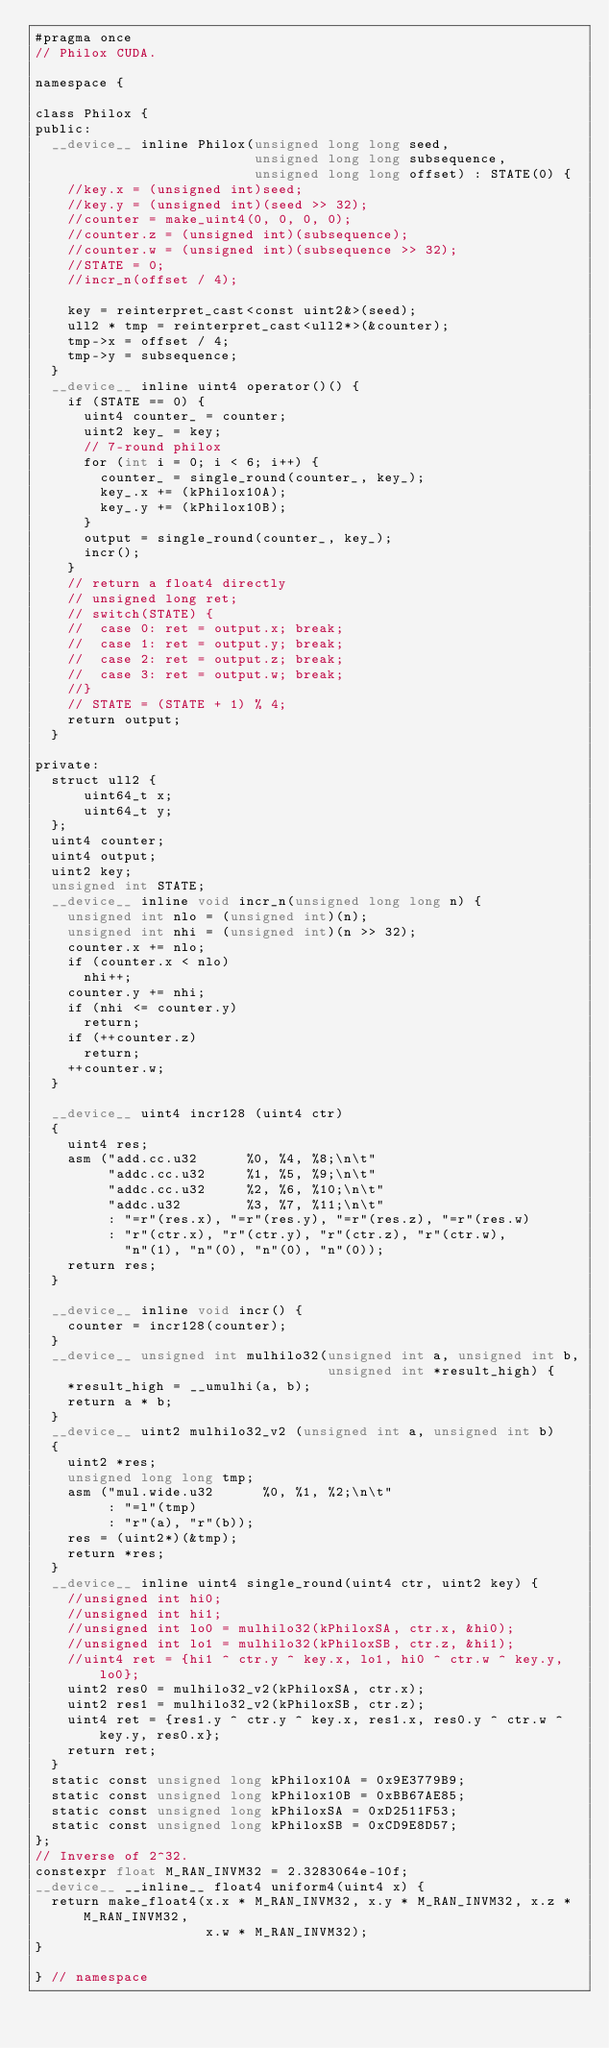<code> <loc_0><loc_0><loc_500><loc_500><_Cuda_>#pragma once
// Philox CUDA.

namespace {

class Philox {
public:
  __device__ inline Philox(unsigned long long seed,
                           unsigned long long subsequence,
                           unsigned long long offset) : STATE(0) {
    //key.x = (unsigned int)seed;
    //key.y = (unsigned int)(seed >> 32);
    //counter = make_uint4(0, 0, 0, 0);
    //counter.z = (unsigned int)(subsequence);
    //counter.w = (unsigned int)(subsequence >> 32);
    //STATE = 0;
    //incr_n(offset / 4);

    key = reinterpret_cast<const uint2&>(seed);
    ull2 * tmp = reinterpret_cast<ull2*>(&counter);
    tmp->x = offset / 4;
    tmp->y = subsequence;
  }
  __device__ inline uint4 operator()() {
    if (STATE == 0) {
      uint4 counter_ = counter;
      uint2 key_ = key;
      // 7-round philox
      for (int i = 0; i < 6; i++) {
        counter_ = single_round(counter_, key_);
        key_.x += (kPhilox10A);
        key_.y += (kPhilox10B);
      }
      output = single_round(counter_, key_);
      incr();
    }
    // return a float4 directly
    // unsigned long ret;
    // switch(STATE) {
    //  case 0: ret = output.x; break;
    //  case 1: ret = output.y; break;
    //  case 2: ret = output.z; break;
    //  case 3: ret = output.w; break;
    //}
    // STATE = (STATE + 1) % 4;
    return output;
  }

private:
  struct ull2 {
      uint64_t x;
      uint64_t y;
  };
  uint4 counter;
  uint4 output;
  uint2 key;
  unsigned int STATE;
  __device__ inline void incr_n(unsigned long long n) {
    unsigned int nlo = (unsigned int)(n);
    unsigned int nhi = (unsigned int)(n >> 32);
    counter.x += nlo;
    if (counter.x < nlo)
      nhi++;
    counter.y += nhi;
    if (nhi <= counter.y)
      return;
    if (++counter.z)
      return;
    ++counter.w;
  }

  __device__ uint4 incr128 (uint4 ctr)
  {
    uint4 res;
    asm ("add.cc.u32      %0, %4, %8;\n\t"
         "addc.cc.u32     %1, %5, %9;\n\t"
         "addc.cc.u32     %2, %6, %10;\n\t"
         "addc.u32        %3, %7, %11;\n\t"
         : "=r"(res.x), "=r"(res.y), "=r"(res.z), "=r"(res.w)
         : "r"(ctr.x), "r"(ctr.y), "r"(ctr.z), "r"(ctr.w),
           "n"(1), "n"(0), "n"(0), "n"(0));
    return res;
  }

  __device__ inline void incr() {
    counter = incr128(counter);
  }
  __device__ unsigned int mulhilo32(unsigned int a, unsigned int b,
                                    unsigned int *result_high) {
    *result_high = __umulhi(a, b);
    return a * b;
  }
  __device__ uint2 mulhilo32_v2 (unsigned int a, unsigned int b)
  {
    uint2 *res;
    unsigned long long tmp;
    asm ("mul.wide.u32      %0, %1, %2;\n\t"
         : "=l"(tmp)
         : "r"(a), "r"(b));
    res = (uint2*)(&tmp);
    return *res;
  }
  __device__ inline uint4 single_round(uint4 ctr, uint2 key) {
    //unsigned int hi0;
    //unsigned int hi1;
    //unsigned int lo0 = mulhilo32(kPhiloxSA, ctr.x, &hi0);
    //unsigned int lo1 = mulhilo32(kPhiloxSB, ctr.z, &hi1);
    //uint4 ret = {hi1 ^ ctr.y ^ key.x, lo1, hi0 ^ ctr.w ^ key.y, lo0};
    uint2 res0 = mulhilo32_v2(kPhiloxSA, ctr.x);
    uint2 res1 = mulhilo32_v2(kPhiloxSB, ctr.z); 
    uint4 ret = {res1.y ^ ctr.y ^ key.x, res1.x, res0.y ^ ctr.w ^ key.y, res0.x};  
    return ret;
  }
  static const unsigned long kPhilox10A = 0x9E3779B9;
  static const unsigned long kPhilox10B = 0xBB67AE85;
  static const unsigned long kPhiloxSA = 0xD2511F53;
  static const unsigned long kPhiloxSB = 0xCD9E8D57;
};
// Inverse of 2^32.
constexpr float M_RAN_INVM32 = 2.3283064e-10f;
__device__ __inline__ float4 uniform4(uint4 x) {
  return make_float4(x.x * M_RAN_INVM32, x.y * M_RAN_INVM32, x.z * M_RAN_INVM32,
                     x.w * M_RAN_INVM32);
}

} // namespace
</code> 